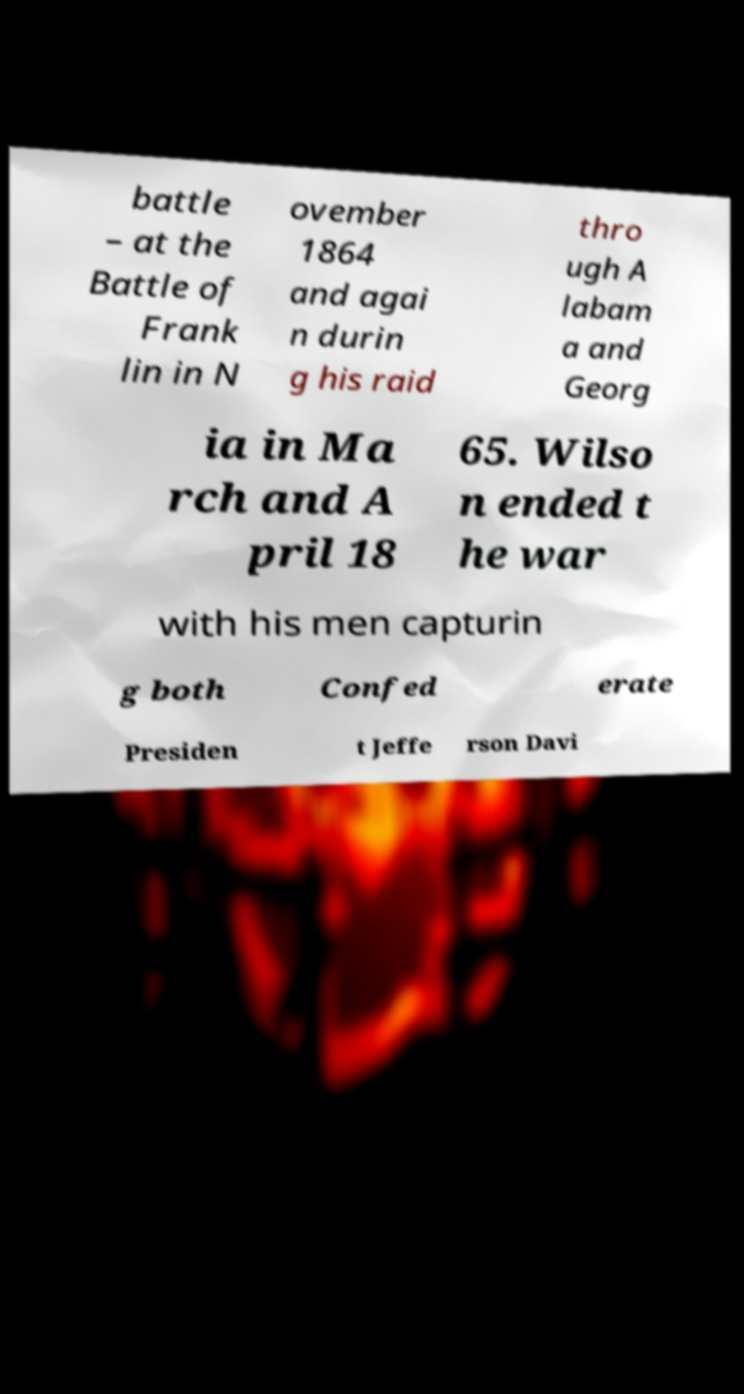Please read and relay the text visible in this image. What does it say? battle – at the Battle of Frank lin in N ovember 1864 and agai n durin g his raid thro ugh A labam a and Georg ia in Ma rch and A pril 18 65. Wilso n ended t he war with his men capturin g both Confed erate Presiden t Jeffe rson Davi 